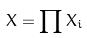<formula> <loc_0><loc_0><loc_500><loc_500>X = \prod X _ { i }</formula> 